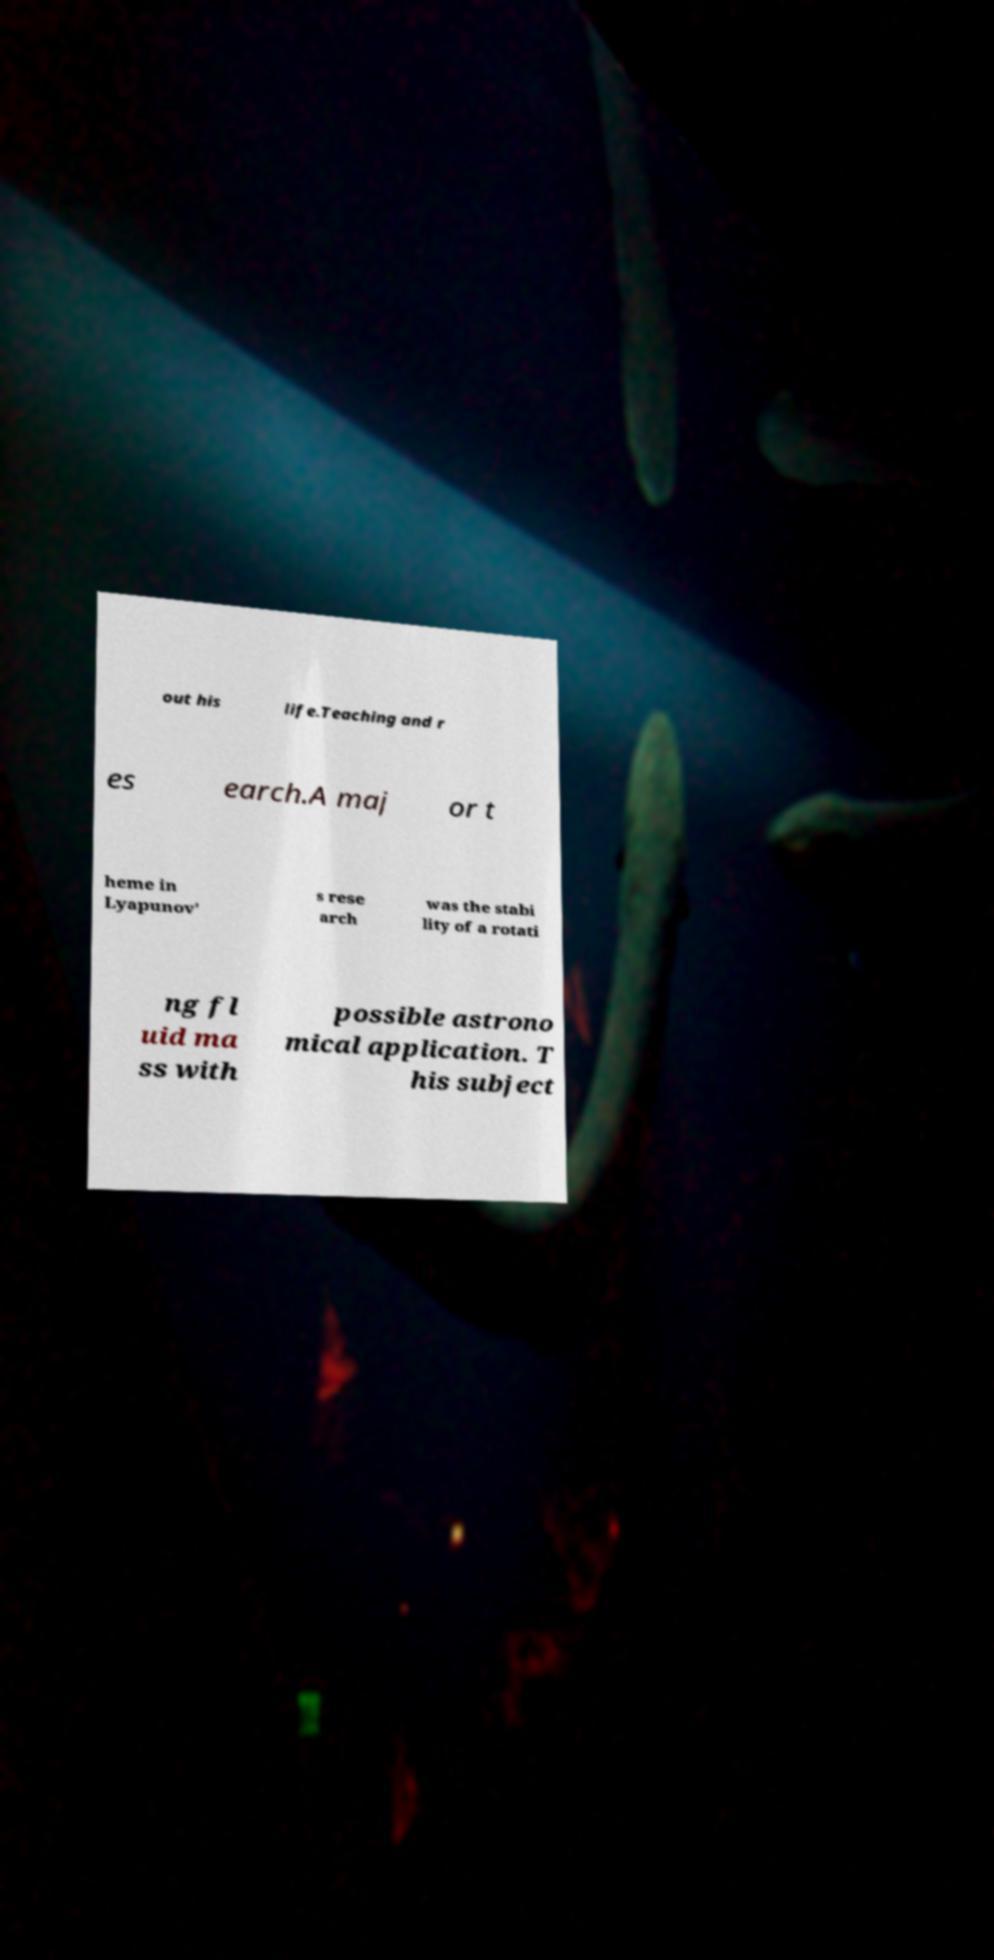Please identify and transcribe the text found in this image. out his life.Teaching and r es earch.A maj or t heme in Lyapunov' s rese arch was the stabi lity of a rotati ng fl uid ma ss with possible astrono mical application. T his subject 